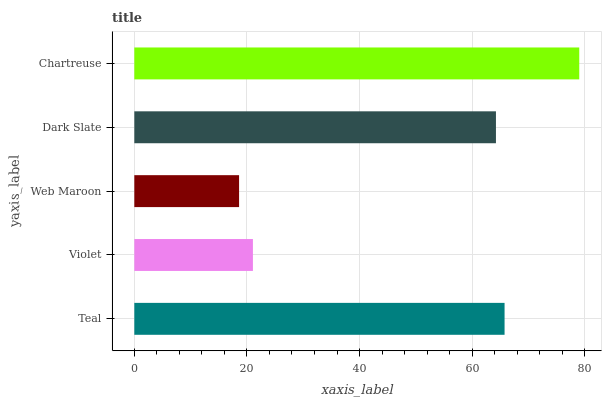Is Web Maroon the minimum?
Answer yes or no. Yes. Is Chartreuse the maximum?
Answer yes or no. Yes. Is Violet the minimum?
Answer yes or no. No. Is Violet the maximum?
Answer yes or no. No. Is Teal greater than Violet?
Answer yes or no. Yes. Is Violet less than Teal?
Answer yes or no. Yes. Is Violet greater than Teal?
Answer yes or no. No. Is Teal less than Violet?
Answer yes or no. No. Is Dark Slate the high median?
Answer yes or no. Yes. Is Dark Slate the low median?
Answer yes or no. Yes. Is Web Maroon the high median?
Answer yes or no. No. Is Web Maroon the low median?
Answer yes or no. No. 